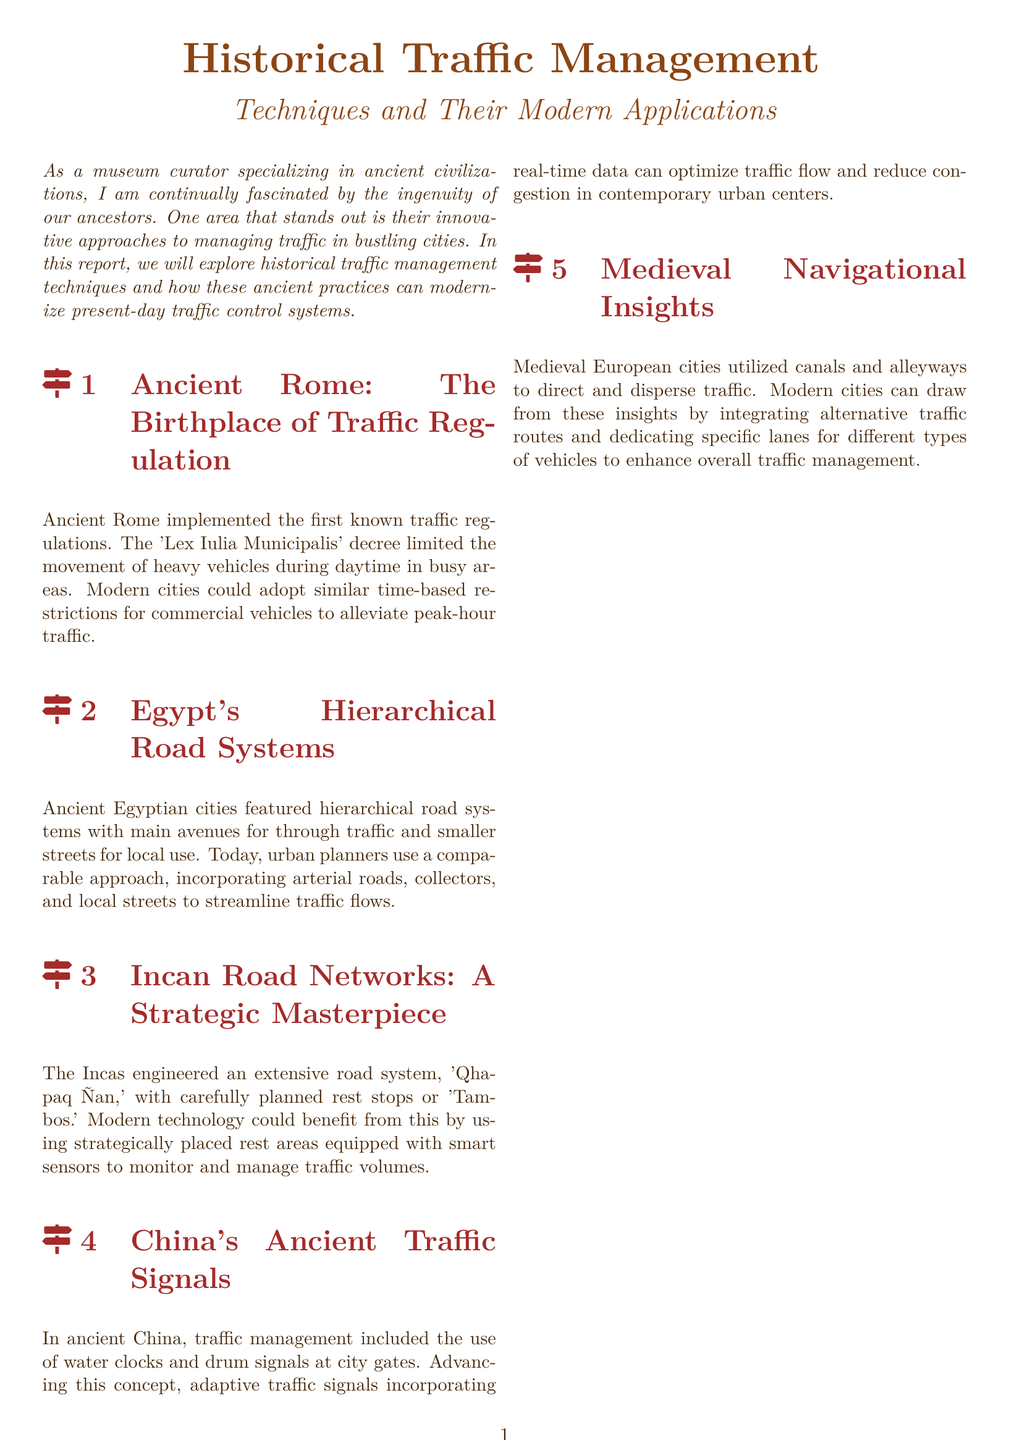What was the decree that limited heavy vehicle movement in Ancient Rome? The document states that the 'Lex Iulia Municipalis' decree was implemented for regulating traffic in Ancient Rome.
Answer: Lex Iulia Municipalis What did the ancient Egyptians use to organize their road systems? The hierarchical road systems featured main avenues for through traffic and smaller streets for local use, as described in the document.
Answer: Hierarchical road systems What is the name of the Incan road system? The document mentions the extensive road system created by the Incas, which is called 'Qhapaq Ñan.'
Answer: Qhapaq Ñan What type of signals were used in ancient China for traffic management? The document indicates that ancient China utilized water clocks and drum signals at city gates for traffic management.
Answer: Water clocks and drum signals What modern traffic management concept is suggested in the report regarding rest areas? The report suggests using strategically placed rest areas equipped with smart sensors to monitor and manage traffic volumes.
Answer: Smart sensors What insight from medieval European cities is suggested for modern traffic management? The document indicates that alternative traffic routes and dedicated lanes for different types of vehicles should be integrated based on medieval navigational insights.
Answer: Alternative traffic routes How does the report conclude about the relationship between ancient wisdom and modern technology? The conclusion in the document highlights that the blend of ancient wisdom and modern technology can transform cities into models of efficient transportation.
Answer: Transform our cities What purpose do adaptive traffic signals serve in modern cities? The document states that adaptive traffic signals incorporating real-time data can optimize traffic flow and reduce congestion.
Answer: Optimize traffic flow What role did rest stops play in the Incan road network? The report points out that the Incas included carefully planned rest stops or 'Tambos' in their extensive road system.
Answer: Tambos 